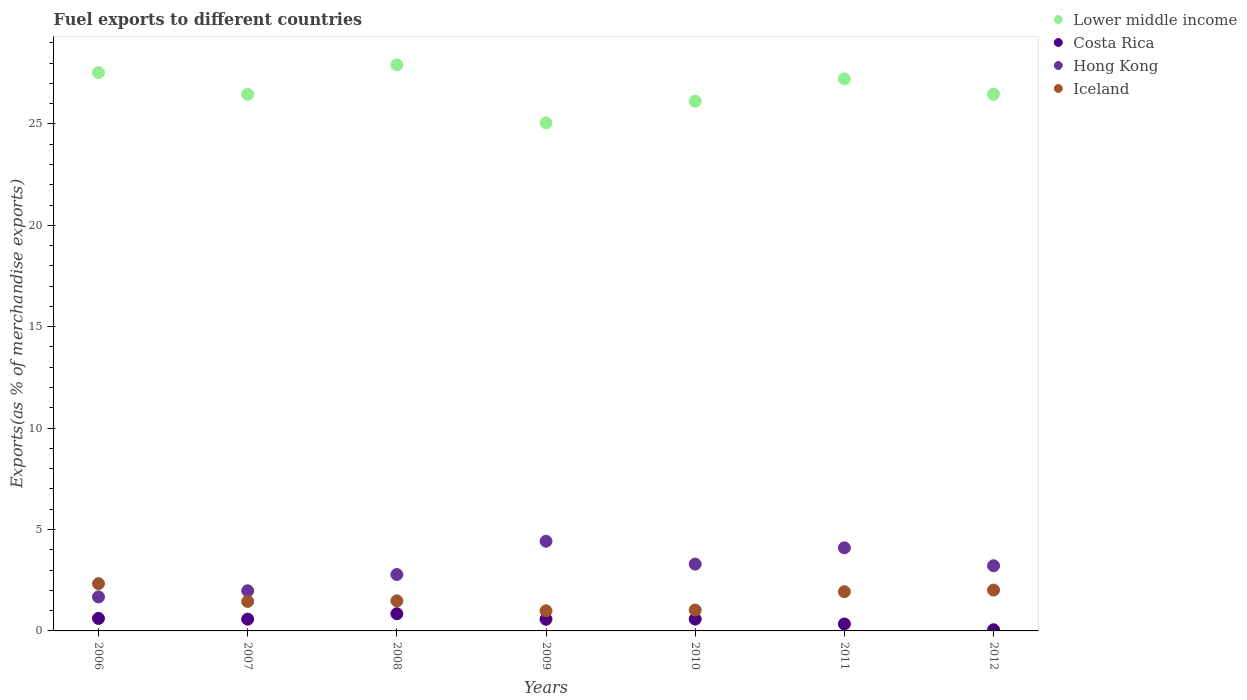How many different coloured dotlines are there?
Offer a terse response. 4. Is the number of dotlines equal to the number of legend labels?
Keep it short and to the point. Yes. What is the percentage of exports to different countries in Hong Kong in 2006?
Offer a terse response. 1.68. Across all years, what is the maximum percentage of exports to different countries in Lower middle income?
Provide a short and direct response. 27.91. Across all years, what is the minimum percentage of exports to different countries in Costa Rica?
Keep it short and to the point. 0.06. In which year was the percentage of exports to different countries in Iceland maximum?
Provide a succinct answer. 2006. In which year was the percentage of exports to different countries in Costa Rica minimum?
Your answer should be compact. 2012. What is the total percentage of exports to different countries in Hong Kong in the graph?
Make the answer very short. 21.46. What is the difference between the percentage of exports to different countries in Costa Rica in 2006 and that in 2009?
Ensure brevity in your answer.  0.04. What is the difference between the percentage of exports to different countries in Lower middle income in 2011 and the percentage of exports to different countries in Costa Rica in 2007?
Make the answer very short. 26.64. What is the average percentage of exports to different countries in Iceland per year?
Offer a terse response. 1.61. In the year 2010, what is the difference between the percentage of exports to different countries in Iceland and percentage of exports to different countries in Hong Kong?
Your response must be concise. -2.27. In how many years, is the percentage of exports to different countries in Lower middle income greater than 4 %?
Make the answer very short. 7. What is the ratio of the percentage of exports to different countries in Iceland in 2008 to that in 2009?
Ensure brevity in your answer.  1.49. What is the difference between the highest and the second highest percentage of exports to different countries in Lower middle income?
Your answer should be very brief. 0.38. What is the difference between the highest and the lowest percentage of exports to different countries in Hong Kong?
Provide a short and direct response. 2.74. Is the sum of the percentage of exports to different countries in Costa Rica in 2010 and 2012 greater than the maximum percentage of exports to different countries in Lower middle income across all years?
Your answer should be very brief. No. Is it the case that in every year, the sum of the percentage of exports to different countries in Costa Rica and percentage of exports to different countries in Hong Kong  is greater than the percentage of exports to different countries in Iceland?
Give a very brief answer. No. Is the percentage of exports to different countries in Hong Kong strictly less than the percentage of exports to different countries in Iceland over the years?
Keep it short and to the point. No. How many years are there in the graph?
Make the answer very short. 7. What is the difference between two consecutive major ticks on the Y-axis?
Provide a succinct answer. 5. Are the values on the major ticks of Y-axis written in scientific E-notation?
Your answer should be compact. No. Where does the legend appear in the graph?
Provide a succinct answer. Top right. How are the legend labels stacked?
Your answer should be compact. Vertical. What is the title of the graph?
Give a very brief answer. Fuel exports to different countries. Does "Algeria" appear as one of the legend labels in the graph?
Ensure brevity in your answer.  No. What is the label or title of the X-axis?
Your answer should be very brief. Years. What is the label or title of the Y-axis?
Offer a terse response. Exports(as % of merchandise exports). What is the Exports(as % of merchandise exports) in Lower middle income in 2006?
Offer a terse response. 27.53. What is the Exports(as % of merchandise exports) in Costa Rica in 2006?
Give a very brief answer. 0.62. What is the Exports(as % of merchandise exports) in Hong Kong in 2006?
Your answer should be compact. 1.68. What is the Exports(as % of merchandise exports) of Iceland in 2006?
Ensure brevity in your answer.  2.33. What is the Exports(as % of merchandise exports) of Lower middle income in 2007?
Your response must be concise. 26.46. What is the Exports(as % of merchandise exports) of Costa Rica in 2007?
Offer a very short reply. 0.58. What is the Exports(as % of merchandise exports) in Hong Kong in 2007?
Provide a short and direct response. 1.98. What is the Exports(as % of merchandise exports) of Iceland in 2007?
Your response must be concise. 1.45. What is the Exports(as % of merchandise exports) in Lower middle income in 2008?
Offer a terse response. 27.91. What is the Exports(as % of merchandise exports) of Costa Rica in 2008?
Ensure brevity in your answer.  0.85. What is the Exports(as % of merchandise exports) of Hong Kong in 2008?
Your answer should be very brief. 2.78. What is the Exports(as % of merchandise exports) of Iceland in 2008?
Keep it short and to the point. 1.48. What is the Exports(as % of merchandise exports) in Lower middle income in 2009?
Your response must be concise. 25.05. What is the Exports(as % of merchandise exports) in Costa Rica in 2009?
Provide a succinct answer. 0.57. What is the Exports(as % of merchandise exports) in Hong Kong in 2009?
Offer a terse response. 4.42. What is the Exports(as % of merchandise exports) of Iceland in 2009?
Give a very brief answer. 0.99. What is the Exports(as % of merchandise exports) of Lower middle income in 2010?
Offer a terse response. 26.12. What is the Exports(as % of merchandise exports) in Costa Rica in 2010?
Offer a very short reply. 0.58. What is the Exports(as % of merchandise exports) of Hong Kong in 2010?
Offer a very short reply. 3.29. What is the Exports(as % of merchandise exports) of Iceland in 2010?
Offer a terse response. 1.03. What is the Exports(as % of merchandise exports) of Lower middle income in 2011?
Keep it short and to the point. 27.22. What is the Exports(as % of merchandise exports) in Costa Rica in 2011?
Your answer should be very brief. 0.34. What is the Exports(as % of merchandise exports) in Hong Kong in 2011?
Provide a succinct answer. 4.1. What is the Exports(as % of merchandise exports) of Iceland in 2011?
Ensure brevity in your answer.  1.93. What is the Exports(as % of merchandise exports) of Lower middle income in 2012?
Provide a succinct answer. 26.46. What is the Exports(as % of merchandise exports) in Costa Rica in 2012?
Make the answer very short. 0.06. What is the Exports(as % of merchandise exports) of Hong Kong in 2012?
Provide a succinct answer. 3.21. What is the Exports(as % of merchandise exports) of Iceland in 2012?
Your answer should be compact. 2.01. Across all years, what is the maximum Exports(as % of merchandise exports) in Lower middle income?
Offer a terse response. 27.91. Across all years, what is the maximum Exports(as % of merchandise exports) of Costa Rica?
Provide a succinct answer. 0.85. Across all years, what is the maximum Exports(as % of merchandise exports) of Hong Kong?
Your answer should be compact. 4.42. Across all years, what is the maximum Exports(as % of merchandise exports) of Iceland?
Your response must be concise. 2.33. Across all years, what is the minimum Exports(as % of merchandise exports) of Lower middle income?
Your answer should be compact. 25.05. Across all years, what is the minimum Exports(as % of merchandise exports) in Costa Rica?
Ensure brevity in your answer.  0.06. Across all years, what is the minimum Exports(as % of merchandise exports) in Hong Kong?
Your response must be concise. 1.68. Across all years, what is the minimum Exports(as % of merchandise exports) of Iceland?
Your answer should be very brief. 0.99. What is the total Exports(as % of merchandise exports) in Lower middle income in the graph?
Your answer should be very brief. 186.76. What is the total Exports(as % of merchandise exports) in Costa Rica in the graph?
Your response must be concise. 3.6. What is the total Exports(as % of merchandise exports) in Hong Kong in the graph?
Your answer should be very brief. 21.46. What is the total Exports(as % of merchandise exports) in Iceland in the graph?
Provide a succinct answer. 11.24. What is the difference between the Exports(as % of merchandise exports) in Lower middle income in 2006 and that in 2007?
Keep it short and to the point. 1.07. What is the difference between the Exports(as % of merchandise exports) in Costa Rica in 2006 and that in 2007?
Keep it short and to the point. 0.04. What is the difference between the Exports(as % of merchandise exports) in Hong Kong in 2006 and that in 2007?
Make the answer very short. -0.3. What is the difference between the Exports(as % of merchandise exports) in Iceland in 2006 and that in 2007?
Ensure brevity in your answer.  0.88. What is the difference between the Exports(as % of merchandise exports) of Lower middle income in 2006 and that in 2008?
Ensure brevity in your answer.  -0.38. What is the difference between the Exports(as % of merchandise exports) in Costa Rica in 2006 and that in 2008?
Provide a short and direct response. -0.23. What is the difference between the Exports(as % of merchandise exports) in Hong Kong in 2006 and that in 2008?
Give a very brief answer. -1.1. What is the difference between the Exports(as % of merchandise exports) of Iceland in 2006 and that in 2008?
Provide a short and direct response. 0.85. What is the difference between the Exports(as % of merchandise exports) in Lower middle income in 2006 and that in 2009?
Ensure brevity in your answer.  2.48. What is the difference between the Exports(as % of merchandise exports) in Costa Rica in 2006 and that in 2009?
Make the answer very short. 0.04. What is the difference between the Exports(as % of merchandise exports) of Hong Kong in 2006 and that in 2009?
Provide a succinct answer. -2.74. What is the difference between the Exports(as % of merchandise exports) in Iceland in 2006 and that in 2009?
Offer a terse response. 1.34. What is the difference between the Exports(as % of merchandise exports) in Lower middle income in 2006 and that in 2010?
Your response must be concise. 1.41. What is the difference between the Exports(as % of merchandise exports) of Costa Rica in 2006 and that in 2010?
Provide a short and direct response. 0.03. What is the difference between the Exports(as % of merchandise exports) in Hong Kong in 2006 and that in 2010?
Keep it short and to the point. -1.62. What is the difference between the Exports(as % of merchandise exports) of Iceland in 2006 and that in 2010?
Provide a succinct answer. 1.3. What is the difference between the Exports(as % of merchandise exports) in Lower middle income in 2006 and that in 2011?
Ensure brevity in your answer.  0.31. What is the difference between the Exports(as % of merchandise exports) of Costa Rica in 2006 and that in 2011?
Give a very brief answer. 0.27. What is the difference between the Exports(as % of merchandise exports) of Hong Kong in 2006 and that in 2011?
Your response must be concise. -2.42. What is the difference between the Exports(as % of merchandise exports) of Iceland in 2006 and that in 2011?
Make the answer very short. 0.4. What is the difference between the Exports(as % of merchandise exports) of Lower middle income in 2006 and that in 2012?
Your answer should be compact. 1.07. What is the difference between the Exports(as % of merchandise exports) in Costa Rica in 2006 and that in 2012?
Provide a short and direct response. 0.56. What is the difference between the Exports(as % of merchandise exports) of Hong Kong in 2006 and that in 2012?
Keep it short and to the point. -1.54. What is the difference between the Exports(as % of merchandise exports) of Iceland in 2006 and that in 2012?
Your answer should be compact. 0.32. What is the difference between the Exports(as % of merchandise exports) in Lower middle income in 2007 and that in 2008?
Offer a very short reply. -1.45. What is the difference between the Exports(as % of merchandise exports) of Costa Rica in 2007 and that in 2008?
Offer a very short reply. -0.27. What is the difference between the Exports(as % of merchandise exports) of Hong Kong in 2007 and that in 2008?
Give a very brief answer. -0.8. What is the difference between the Exports(as % of merchandise exports) in Iceland in 2007 and that in 2008?
Make the answer very short. -0.03. What is the difference between the Exports(as % of merchandise exports) of Lower middle income in 2007 and that in 2009?
Offer a very short reply. 1.41. What is the difference between the Exports(as % of merchandise exports) of Costa Rica in 2007 and that in 2009?
Make the answer very short. 0.01. What is the difference between the Exports(as % of merchandise exports) of Hong Kong in 2007 and that in 2009?
Your answer should be very brief. -2.44. What is the difference between the Exports(as % of merchandise exports) in Iceland in 2007 and that in 2009?
Ensure brevity in your answer.  0.46. What is the difference between the Exports(as % of merchandise exports) in Lower middle income in 2007 and that in 2010?
Offer a terse response. 0.34. What is the difference between the Exports(as % of merchandise exports) of Costa Rica in 2007 and that in 2010?
Provide a succinct answer. -0. What is the difference between the Exports(as % of merchandise exports) in Hong Kong in 2007 and that in 2010?
Make the answer very short. -1.31. What is the difference between the Exports(as % of merchandise exports) of Iceland in 2007 and that in 2010?
Offer a very short reply. 0.43. What is the difference between the Exports(as % of merchandise exports) in Lower middle income in 2007 and that in 2011?
Make the answer very short. -0.76. What is the difference between the Exports(as % of merchandise exports) in Costa Rica in 2007 and that in 2011?
Offer a terse response. 0.24. What is the difference between the Exports(as % of merchandise exports) in Hong Kong in 2007 and that in 2011?
Offer a very short reply. -2.12. What is the difference between the Exports(as % of merchandise exports) in Iceland in 2007 and that in 2011?
Give a very brief answer. -0.48. What is the difference between the Exports(as % of merchandise exports) of Lower middle income in 2007 and that in 2012?
Offer a very short reply. -0. What is the difference between the Exports(as % of merchandise exports) in Costa Rica in 2007 and that in 2012?
Give a very brief answer. 0.52. What is the difference between the Exports(as % of merchandise exports) in Hong Kong in 2007 and that in 2012?
Offer a very short reply. -1.23. What is the difference between the Exports(as % of merchandise exports) in Iceland in 2007 and that in 2012?
Keep it short and to the point. -0.56. What is the difference between the Exports(as % of merchandise exports) in Lower middle income in 2008 and that in 2009?
Provide a succinct answer. 2.86. What is the difference between the Exports(as % of merchandise exports) in Costa Rica in 2008 and that in 2009?
Your answer should be very brief. 0.27. What is the difference between the Exports(as % of merchandise exports) of Hong Kong in 2008 and that in 2009?
Your answer should be very brief. -1.64. What is the difference between the Exports(as % of merchandise exports) in Iceland in 2008 and that in 2009?
Give a very brief answer. 0.49. What is the difference between the Exports(as % of merchandise exports) in Lower middle income in 2008 and that in 2010?
Your answer should be compact. 1.8. What is the difference between the Exports(as % of merchandise exports) in Costa Rica in 2008 and that in 2010?
Provide a succinct answer. 0.27. What is the difference between the Exports(as % of merchandise exports) in Hong Kong in 2008 and that in 2010?
Offer a very short reply. -0.51. What is the difference between the Exports(as % of merchandise exports) of Iceland in 2008 and that in 2010?
Offer a very short reply. 0.45. What is the difference between the Exports(as % of merchandise exports) of Lower middle income in 2008 and that in 2011?
Make the answer very short. 0.69. What is the difference between the Exports(as % of merchandise exports) of Costa Rica in 2008 and that in 2011?
Give a very brief answer. 0.51. What is the difference between the Exports(as % of merchandise exports) of Hong Kong in 2008 and that in 2011?
Offer a very short reply. -1.32. What is the difference between the Exports(as % of merchandise exports) of Iceland in 2008 and that in 2011?
Provide a succinct answer. -0.45. What is the difference between the Exports(as % of merchandise exports) in Lower middle income in 2008 and that in 2012?
Make the answer very short. 1.45. What is the difference between the Exports(as % of merchandise exports) of Costa Rica in 2008 and that in 2012?
Give a very brief answer. 0.79. What is the difference between the Exports(as % of merchandise exports) in Hong Kong in 2008 and that in 2012?
Keep it short and to the point. -0.43. What is the difference between the Exports(as % of merchandise exports) of Iceland in 2008 and that in 2012?
Keep it short and to the point. -0.53. What is the difference between the Exports(as % of merchandise exports) of Lower middle income in 2009 and that in 2010?
Your response must be concise. -1.07. What is the difference between the Exports(as % of merchandise exports) of Costa Rica in 2009 and that in 2010?
Make the answer very short. -0.01. What is the difference between the Exports(as % of merchandise exports) of Hong Kong in 2009 and that in 2010?
Provide a succinct answer. 1.13. What is the difference between the Exports(as % of merchandise exports) of Iceland in 2009 and that in 2010?
Offer a terse response. -0.04. What is the difference between the Exports(as % of merchandise exports) in Lower middle income in 2009 and that in 2011?
Keep it short and to the point. -2.17. What is the difference between the Exports(as % of merchandise exports) in Costa Rica in 2009 and that in 2011?
Make the answer very short. 0.23. What is the difference between the Exports(as % of merchandise exports) of Hong Kong in 2009 and that in 2011?
Your response must be concise. 0.32. What is the difference between the Exports(as % of merchandise exports) of Iceland in 2009 and that in 2011?
Your answer should be very brief. -0.94. What is the difference between the Exports(as % of merchandise exports) in Lower middle income in 2009 and that in 2012?
Your answer should be compact. -1.41. What is the difference between the Exports(as % of merchandise exports) in Costa Rica in 2009 and that in 2012?
Offer a very short reply. 0.52. What is the difference between the Exports(as % of merchandise exports) in Hong Kong in 2009 and that in 2012?
Your response must be concise. 1.21. What is the difference between the Exports(as % of merchandise exports) of Iceland in 2009 and that in 2012?
Give a very brief answer. -1.02. What is the difference between the Exports(as % of merchandise exports) in Lower middle income in 2010 and that in 2011?
Give a very brief answer. -1.1. What is the difference between the Exports(as % of merchandise exports) of Costa Rica in 2010 and that in 2011?
Provide a succinct answer. 0.24. What is the difference between the Exports(as % of merchandise exports) in Hong Kong in 2010 and that in 2011?
Provide a short and direct response. -0.8. What is the difference between the Exports(as % of merchandise exports) of Iceland in 2010 and that in 2011?
Your answer should be compact. -0.9. What is the difference between the Exports(as % of merchandise exports) of Lower middle income in 2010 and that in 2012?
Your response must be concise. -0.35. What is the difference between the Exports(as % of merchandise exports) in Costa Rica in 2010 and that in 2012?
Provide a succinct answer. 0.53. What is the difference between the Exports(as % of merchandise exports) of Hong Kong in 2010 and that in 2012?
Offer a very short reply. 0.08. What is the difference between the Exports(as % of merchandise exports) of Iceland in 2010 and that in 2012?
Your response must be concise. -0.99. What is the difference between the Exports(as % of merchandise exports) of Lower middle income in 2011 and that in 2012?
Provide a succinct answer. 0.76. What is the difference between the Exports(as % of merchandise exports) in Costa Rica in 2011 and that in 2012?
Ensure brevity in your answer.  0.29. What is the difference between the Exports(as % of merchandise exports) in Hong Kong in 2011 and that in 2012?
Offer a very short reply. 0.88. What is the difference between the Exports(as % of merchandise exports) in Iceland in 2011 and that in 2012?
Provide a short and direct response. -0.08. What is the difference between the Exports(as % of merchandise exports) of Lower middle income in 2006 and the Exports(as % of merchandise exports) of Costa Rica in 2007?
Your response must be concise. 26.95. What is the difference between the Exports(as % of merchandise exports) in Lower middle income in 2006 and the Exports(as % of merchandise exports) in Hong Kong in 2007?
Offer a very short reply. 25.55. What is the difference between the Exports(as % of merchandise exports) of Lower middle income in 2006 and the Exports(as % of merchandise exports) of Iceland in 2007?
Provide a succinct answer. 26.08. What is the difference between the Exports(as % of merchandise exports) of Costa Rica in 2006 and the Exports(as % of merchandise exports) of Hong Kong in 2007?
Your response must be concise. -1.36. What is the difference between the Exports(as % of merchandise exports) of Costa Rica in 2006 and the Exports(as % of merchandise exports) of Iceland in 2007?
Keep it short and to the point. -0.84. What is the difference between the Exports(as % of merchandise exports) of Hong Kong in 2006 and the Exports(as % of merchandise exports) of Iceland in 2007?
Ensure brevity in your answer.  0.22. What is the difference between the Exports(as % of merchandise exports) of Lower middle income in 2006 and the Exports(as % of merchandise exports) of Costa Rica in 2008?
Your response must be concise. 26.68. What is the difference between the Exports(as % of merchandise exports) of Lower middle income in 2006 and the Exports(as % of merchandise exports) of Hong Kong in 2008?
Your answer should be compact. 24.75. What is the difference between the Exports(as % of merchandise exports) of Lower middle income in 2006 and the Exports(as % of merchandise exports) of Iceland in 2008?
Keep it short and to the point. 26.05. What is the difference between the Exports(as % of merchandise exports) in Costa Rica in 2006 and the Exports(as % of merchandise exports) in Hong Kong in 2008?
Ensure brevity in your answer.  -2.17. What is the difference between the Exports(as % of merchandise exports) of Costa Rica in 2006 and the Exports(as % of merchandise exports) of Iceland in 2008?
Provide a succinct answer. -0.87. What is the difference between the Exports(as % of merchandise exports) of Hong Kong in 2006 and the Exports(as % of merchandise exports) of Iceland in 2008?
Your response must be concise. 0.19. What is the difference between the Exports(as % of merchandise exports) of Lower middle income in 2006 and the Exports(as % of merchandise exports) of Costa Rica in 2009?
Offer a very short reply. 26.96. What is the difference between the Exports(as % of merchandise exports) in Lower middle income in 2006 and the Exports(as % of merchandise exports) in Hong Kong in 2009?
Provide a succinct answer. 23.11. What is the difference between the Exports(as % of merchandise exports) of Lower middle income in 2006 and the Exports(as % of merchandise exports) of Iceland in 2009?
Offer a terse response. 26.54. What is the difference between the Exports(as % of merchandise exports) in Costa Rica in 2006 and the Exports(as % of merchandise exports) in Hong Kong in 2009?
Ensure brevity in your answer.  -3.81. What is the difference between the Exports(as % of merchandise exports) in Costa Rica in 2006 and the Exports(as % of merchandise exports) in Iceland in 2009?
Your answer should be compact. -0.38. What is the difference between the Exports(as % of merchandise exports) in Hong Kong in 2006 and the Exports(as % of merchandise exports) in Iceland in 2009?
Provide a short and direct response. 0.68. What is the difference between the Exports(as % of merchandise exports) of Lower middle income in 2006 and the Exports(as % of merchandise exports) of Costa Rica in 2010?
Your answer should be compact. 26.95. What is the difference between the Exports(as % of merchandise exports) of Lower middle income in 2006 and the Exports(as % of merchandise exports) of Hong Kong in 2010?
Your response must be concise. 24.24. What is the difference between the Exports(as % of merchandise exports) in Lower middle income in 2006 and the Exports(as % of merchandise exports) in Iceland in 2010?
Keep it short and to the point. 26.5. What is the difference between the Exports(as % of merchandise exports) in Costa Rica in 2006 and the Exports(as % of merchandise exports) in Hong Kong in 2010?
Your answer should be compact. -2.68. What is the difference between the Exports(as % of merchandise exports) of Costa Rica in 2006 and the Exports(as % of merchandise exports) of Iceland in 2010?
Provide a succinct answer. -0.41. What is the difference between the Exports(as % of merchandise exports) of Hong Kong in 2006 and the Exports(as % of merchandise exports) of Iceland in 2010?
Your answer should be very brief. 0.65. What is the difference between the Exports(as % of merchandise exports) of Lower middle income in 2006 and the Exports(as % of merchandise exports) of Costa Rica in 2011?
Offer a terse response. 27.19. What is the difference between the Exports(as % of merchandise exports) in Lower middle income in 2006 and the Exports(as % of merchandise exports) in Hong Kong in 2011?
Make the answer very short. 23.43. What is the difference between the Exports(as % of merchandise exports) in Lower middle income in 2006 and the Exports(as % of merchandise exports) in Iceland in 2011?
Ensure brevity in your answer.  25.6. What is the difference between the Exports(as % of merchandise exports) of Costa Rica in 2006 and the Exports(as % of merchandise exports) of Hong Kong in 2011?
Give a very brief answer. -3.48. What is the difference between the Exports(as % of merchandise exports) in Costa Rica in 2006 and the Exports(as % of merchandise exports) in Iceland in 2011?
Offer a very short reply. -1.32. What is the difference between the Exports(as % of merchandise exports) of Hong Kong in 2006 and the Exports(as % of merchandise exports) of Iceland in 2011?
Keep it short and to the point. -0.26. What is the difference between the Exports(as % of merchandise exports) of Lower middle income in 2006 and the Exports(as % of merchandise exports) of Costa Rica in 2012?
Give a very brief answer. 27.47. What is the difference between the Exports(as % of merchandise exports) of Lower middle income in 2006 and the Exports(as % of merchandise exports) of Hong Kong in 2012?
Keep it short and to the point. 24.32. What is the difference between the Exports(as % of merchandise exports) in Lower middle income in 2006 and the Exports(as % of merchandise exports) in Iceland in 2012?
Offer a very short reply. 25.52. What is the difference between the Exports(as % of merchandise exports) of Costa Rica in 2006 and the Exports(as % of merchandise exports) of Hong Kong in 2012?
Give a very brief answer. -2.6. What is the difference between the Exports(as % of merchandise exports) in Costa Rica in 2006 and the Exports(as % of merchandise exports) in Iceland in 2012?
Offer a very short reply. -1.4. What is the difference between the Exports(as % of merchandise exports) in Hong Kong in 2006 and the Exports(as % of merchandise exports) in Iceland in 2012?
Your response must be concise. -0.34. What is the difference between the Exports(as % of merchandise exports) of Lower middle income in 2007 and the Exports(as % of merchandise exports) of Costa Rica in 2008?
Your response must be concise. 25.61. What is the difference between the Exports(as % of merchandise exports) of Lower middle income in 2007 and the Exports(as % of merchandise exports) of Hong Kong in 2008?
Keep it short and to the point. 23.68. What is the difference between the Exports(as % of merchandise exports) in Lower middle income in 2007 and the Exports(as % of merchandise exports) in Iceland in 2008?
Give a very brief answer. 24.98. What is the difference between the Exports(as % of merchandise exports) of Costa Rica in 2007 and the Exports(as % of merchandise exports) of Hong Kong in 2008?
Give a very brief answer. -2.2. What is the difference between the Exports(as % of merchandise exports) of Costa Rica in 2007 and the Exports(as % of merchandise exports) of Iceland in 2008?
Your answer should be very brief. -0.9. What is the difference between the Exports(as % of merchandise exports) in Hong Kong in 2007 and the Exports(as % of merchandise exports) in Iceland in 2008?
Keep it short and to the point. 0.5. What is the difference between the Exports(as % of merchandise exports) of Lower middle income in 2007 and the Exports(as % of merchandise exports) of Costa Rica in 2009?
Offer a very short reply. 25.89. What is the difference between the Exports(as % of merchandise exports) of Lower middle income in 2007 and the Exports(as % of merchandise exports) of Hong Kong in 2009?
Provide a succinct answer. 22.04. What is the difference between the Exports(as % of merchandise exports) of Lower middle income in 2007 and the Exports(as % of merchandise exports) of Iceland in 2009?
Ensure brevity in your answer.  25.47. What is the difference between the Exports(as % of merchandise exports) of Costa Rica in 2007 and the Exports(as % of merchandise exports) of Hong Kong in 2009?
Provide a short and direct response. -3.84. What is the difference between the Exports(as % of merchandise exports) of Costa Rica in 2007 and the Exports(as % of merchandise exports) of Iceland in 2009?
Your answer should be very brief. -0.41. What is the difference between the Exports(as % of merchandise exports) of Hong Kong in 2007 and the Exports(as % of merchandise exports) of Iceland in 2009?
Your answer should be very brief. 0.99. What is the difference between the Exports(as % of merchandise exports) in Lower middle income in 2007 and the Exports(as % of merchandise exports) in Costa Rica in 2010?
Your answer should be compact. 25.88. What is the difference between the Exports(as % of merchandise exports) of Lower middle income in 2007 and the Exports(as % of merchandise exports) of Hong Kong in 2010?
Your answer should be very brief. 23.17. What is the difference between the Exports(as % of merchandise exports) of Lower middle income in 2007 and the Exports(as % of merchandise exports) of Iceland in 2010?
Offer a very short reply. 25.43. What is the difference between the Exports(as % of merchandise exports) of Costa Rica in 2007 and the Exports(as % of merchandise exports) of Hong Kong in 2010?
Keep it short and to the point. -2.71. What is the difference between the Exports(as % of merchandise exports) in Costa Rica in 2007 and the Exports(as % of merchandise exports) in Iceland in 2010?
Your answer should be compact. -0.45. What is the difference between the Exports(as % of merchandise exports) in Hong Kong in 2007 and the Exports(as % of merchandise exports) in Iceland in 2010?
Offer a very short reply. 0.95. What is the difference between the Exports(as % of merchandise exports) of Lower middle income in 2007 and the Exports(as % of merchandise exports) of Costa Rica in 2011?
Provide a succinct answer. 26.12. What is the difference between the Exports(as % of merchandise exports) of Lower middle income in 2007 and the Exports(as % of merchandise exports) of Hong Kong in 2011?
Provide a short and direct response. 22.36. What is the difference between the Exports(as % of merchandise exports) in Lower middle income in 2007 and the Exports(as % of merchandise exports) in Iceland in 2011?
Make the answer very short. 24.53. What is the difference between the Exports(as % of merchandise exports) in Costa Rica in 2007 and the Exports(as % of merchandise exports) in Hong Kong in 2011?
Provide a succinct answer. -3.52. What is the difference between the Exports(as % of merchandise exports) of Costa Rica in 2007 and the Exports(as % of merchandise exports) of Iceland in 2011?
Your answer should be very brief. -1.35. What is the difference between the Exports(as % of merchandise exports) in Hong Kong in 2007 and the Exports(as % of merchandise exports) in Iceland in 2011?
Provide a succinct answer. 0.05. What is the difference between the Exports(as % of merchandise exports) of Lower middle income in 2007 and the Exports(as % of merchandise exports) of Costa Rica in 2012?
Your response must be concise. 26.4. What is the difference between the Exports(as % of merchandise exports) of Lower middle income in 2007 and the Exports(as % of merchandise exports) of Hong Kong in 2012?
Give a very brief answer. 23.25. What is the difference between the Exports(as % of merchandise exports) of Lower middle income in 2007 and the Exports(as % of merchandise exports) of Iceland in 2012?
Your response must be concise. 24.45. What is the difference between the Exports(as % of merchandise exports) of Costa Rica in 2007 and the Exports(as % of merchandise exports) of Hong Kong in 2012?
Ensure brevity in your answer.  -2.63. What is the difference between the Exports(as % of merchandise exports) in Costa Rica in 2007 and the Exports(as % of merchandise exports) in Iceland in 2012?
Your response must be concise. -1.43. What is the difference between the Exports(as % of merchandise exports) in Hong Kong in 2007 and the Exports(as % of merchandise exports) in Iceland in 2012?
Provide a short and direct response. -0.03. What is the difference between the Exports(as % of merchandise exports) in Lower middle income in 2008 and the Exports(as % of merchandise exports) in Costa Rica in 2009?
Keep it short and to the point. 27.34. What is the difference between the Exports(as % of merchandise exports) in Lower middle income in 2008 and the Exports(as % of merchandise exports) in Hong Kong in 2009?
Give a very brief answer. 23.49. What is the difference between the Exports(as % of merchandise exports) of Lower middle income in 2008 and the Exports(as % of merchandise exports) of Iceland in 2009?
Your response must be concise. 26.92. What is the difference between the Exports(as % of merchandise exports) of Costa Rica in 2008 and the Exports(as % of merchandise exports) of Hong Kong in 2009?
Your response must be concise. -3.57. What is the difference between the Exports(as % of merchandise exports) of Costa Rica in 2008 and the Exports(as % of merchandise exports) of Iceland in 2009?
Give a very brief answer. -0.14. What is the difference between the Exports(as % of merchandise exports) of Hong Kong in 2008 and the Exports(as % of merchandise exports) of Iceland in 2009?
Offer a terse response. 1.79. What is the difference between the Exports(as % of merchandise exports) of Lower middle income in 2008 and the Exports(as % of merchandise exports) of Costa Rica in 2010?
Your answer should be very brief. 27.33. What is the difference between the Exports(as % of merchandise exports) of Lower middle income in 2008 and the Exports(as % of merchandise exports) of Hong Kong in 2010?
Offer a terse response. 24.62. What is the difference between the Exports(as % of merchandise exports) in Lower middle income in 2008 and the Exports(as % of merchandise exports) in Iceland in 2010?
Provide a succinct answer. 26.88. What is the difference between the Exports(as % of merchandise exports) in Costa Rica in 2008 and the Exports(as % of merchandise exports) in Hong Kong in 2010?
Offer a very short reply. -2.45. What is the difference between the Exports(as % of merchandise exports) in Costa Rica in 2008 and the Exports(as % of merchandise exports) in Iceland in 2010?
Ensure brevity in your answer.  -0.18. What is the difference between the Exports(as % of merchandise exports) of Hong Kong in 2008 and the Exports(as % of merchandise exports) of Iceland in 2010?
Keep it short and to the point. 1.75. What is the difference between the Exports(as % of merchandise exports) in Lower middle income in 2008 and the Exports(as % of merchandise exports) in Costa Rica in 2011?
Provide a short and direct response. 27.57. What is the difference between the Exports(as % of merchandise exports) in Lower middle income in 2008 and the Exports(as % of merchandise exports) in Hong Kong in 2011?
Your answer should be very brief. 23.82. What is the difference between the Exports(as % of merchandise exports) of Lower middle income in 2008 and the Exports(as % of merchandise exports) of Iceland in 2011?
Give a very brief answer. 25.98. What is the difference between the Exports(as % of merchandise exports) of Costa Rica in 2008 and the Exports(as % of merchandise exports) of Hong Kong in 2011?
Offer a very short reply. -3.25. What is the difference between the Exports(as % of merchandise exports) in Costa Rica in 2008 and the Exports(as % of merchandise exports) in Iceland in 2011?
Ensure brevity in your answer.  -1.08. What is the difference between the Exports(as % of merchandise exports) of Hong Kong in 2008 and the Exports(as % of merchandise exports) of Iceland in 2011?
Ensure brevity in your answer.  0.85. What is the difference between the Exports(as % of merchandise exports) in Lower middle income in 2008 and the Exports(as % of merchandise exports) in Costa Rica in 2012?
Give a very brief answer. 27.86. What is the difference between the Exports(as % of merchandise exports) in Lower middle income in 2008 and the Exports(as % of merchandise exports) in Hong Kong in 2012?
Make the answer very short. 24.7. What is the difference between the Exports(as % of merchandise exports) of Lower middle income in 2008 and the Exports(as % of merchandise exports) of Iceland in 2012?
Your answer should be very brief. 25.9. What is the difference between the Exports(as % of merchandise exports) of Costa Rica in 2008 and the Exports(as % of merchandise exports) of Hong Kong in 2012?
Provide a succinct answer. -2.36. What is the difference between the Exports(as % of merchandise exports) of Costa Rica in 2008 and the Exports(as % of merchandise exports) of Iceland in 2012?
Offer a terse response. -1.17. What is the difference between the Exports(as % of merchandise exports) of Hong Kong in 2008 and the Exports(as % of merchandise exports) of Iceland in 2012?
Ensure brevity in your answer.  0.77. What is the difference between the Exports(as % of merchandise exports) of Lower middle income in 2009 and the Exports(as % of merchandise exports) of Costa Rica in 2010?
Offer a terse response. 24.47. What is the difference between the Exports(as % of merchandise exports) in Lower middle income in 2009 and the Exports(as % of merchandise exports) in Hong Kong in 2010?
Offer a very short reply. 21.76. What is the difference between the Exports(as % of merchandise exports) of Lower middle income in 2009 and the Exports(as % of merchandise exports) of Iceland in 2010?
Give a very brief answer. 24.02. What is the difference between the Exports(as % of merchandise exports) in Costa Rica in 2009 and the Exports(as % of merchandise exports) in Hong Kong in 2010?
Provide a short and direct response. -2.72. What is the difference between the Exports(as % of merchandise exports) in Costa Rica in 2009 and the Exports(as % of merchandise exports) in Iceland in 2010?
Provide a succinct answer. -0.45. What is the difference between the Exports(as % of merchandise exports) in Hong Kong in 2009 and the Exports(as % of merchandise exports) in Iceland in 2010?
Your answer should be compact. 3.39. What is the difference between the Exports(as % of merchandise exports) in Lower middle income in 2009 and the Exports(as % of merchandise exports) in Costa Rica in 2011?
Provide a short and direct response. 24.71. What is the difference between the Exports(as % of merchandise exports) in Lower middle income in 2009 and the Exports(as % of merchandise exports) in Hong Kong in 2011?
Your answer should be very brief. 20.95. What is the difference between the Exports(as % of merchandise exports) of Lower middle income in 2009 and the Exports(as % of merchandise exports) of Iceland in 2011?
Offer a very short reply. 23.12. What is the difference between the Exports(as % of merchandise exports) in Costa Rica in 2009 and the Exports(as % of merchandise exports) in Hong Kong in 2011?
Provide a short and direct response. -3.52. What is the difference between the Exports(as % of merchandise exports) in Costa Rica in 2009 and the Exports(as % of merchandise exports) in Iceland in 2011?
Keep it short and to the point. -1.36. What is the difference between the Exports(as % of merchandise exports) of Hong Kong in 2009 and the Exports(as % of merchandise exports) of Iceland in 2011?
Your answer should be compact. 2.49. What is the difference between the Exports(as % of merchandise exports) of Lower middle income in 2009 and the Exports(as % of merchandise exports) of Costa Rica in 2012?
Give a very brief answer. 24.99. What is the difference between the Exports(as % of merchandise exports) in Lower middle income in 2009 and the Exports(as % of merchandise exports) in Hong Kong in 2012?
Provide a short and direct response. 21.84. What is the difference between the Exports(as % of merchandise exports) of Lower middle income in 2009 and the Exports(as % of merchandise exports) of Iceland in 2012?
Make the answer very short. 23.04. What is the difference between the Exports(as % of merchandise exports) of Costa Rica in 2009 and the Exports(as % of merchandise exports) of Hong Kong in 2012?
Your answer should be compact. -2.64. What is the difference between the Exports(as % of merchandise exports) in Costa Rica in 2009 and the Exports(as % of merchandise exports) in Iceland in 2012?
Make the answer very short. -1.44. What is the difference between the Exports(as % of merchandise exports) in Hong Kong in 2009 and the Exports(as % of merchandise exports) in Iceland in 2012?
Make the answer very short. 2.41. What is the difference between the Exports(as % of merchandise exports) in Lower middle income in 2010 and the Exports(as % of merchandise exports) in Costa Rica in 2011?
Ensure brevity in your answer.  25.77. What is the difference between the Exports(as % of merchandise exports) of Lower middle income in 2010 and the Exports(as % of merchandise exports) of Hong Kong in 2011?
Ensure brevity in your answer.  22.02. What is the difference between the Exports(as % of merchandise exports) of Lower middle income in 2010 and the Exports(as % of merchandise exports) of Iceland in 2011?
Provide a short and direct response. 24.18. What is the difference between the Exports(as % of merchandise exports) in Costa Rica in 2010 and the Exports(as % of merchandise exports) in Hong Kong in 2011?
Make the answer very short. -3.52. What is the difference between the Exports(as % of merchandise exports) in Costa Rica in 2010 and the Exports(as % of merchandise exports) in Iceland in 2011?
Your answer should be compact. -1.35. What is the difference between the Exports(as % of merchandise exports) in Hong Kong in 2010 and the Exports(as % of merchandise exports) in Iceland in 2011?
Your answer should be very brief. 1.36. What is the difference between the Exports(as % of merchandise exports) of Lower middle income in 2010 and the Exports(as % of merchandise exports) of Costa Rica in 2012?
Provide a short and direct response. 26.06. What is the difference between the Exports(as % of merchandise exports) of Lower middle income in 2010 and the Exports(as % of merchandise exports) of Hong Kong in 2012?
Ensure brevity in your answer.  22.9. What is the difference between the Exports(as % of merchandise exports) of Lower middle income in 2010 and the Exports(as % of merchandise exports) of Iceland in 2012?
Make the answer very short. 24.1. What is the difference between the Exports(as % of merchandise exports) of Costa Rica in 2010 and the Exports(as % of merchandise exports) of Hong Kong in 2012?
Offer a terse response. -2.63. What is the difference between the Exports(as % of merchandise exports) in Costa Rica in 2010 and the Exports(as % of merchandise exports) in Iceland in 2012?
Give a very brief answer. -1.43. What is the difference between the Exports(as % of merchandise exports) in Hong Kong in 2010 and the Exports(as % of merchandise exports) in Iceland in 2012?
Make the answer very short. 1.28. What is the difference between the Exports(as % of merchandise exports) in Lower middle income in 2011 and the Exports(as % of merchandise exports) in Costa Rica in 2012?
Your response must be concise. 27.17. What is the difference between the Exports(as % of merchandise exports) of Lower middle income in 2011 and the Exports(as % of merchandise exports) of Hong Kong in 2012?
Ensure brevity in your answer.  24.01. What is the difference between the Exports(as % of merchandise exports) of Lower middle income in 2011 and the Exports(as % of merchandise exports) of Iceland in 2012?
Provide a succinct answer. 25.21. What is the difference between the Exports(as % of merchandise exports) of Costa Rica in 2011 and the Exports(as % of merchandise exports) of Hong Kong in 2012?
Give a very brief answer. -2.87. What is the difference between the Exports(as % of merchandise exports) in Costa Rica in 2011 and the Exports(as % of merchandise exports) in Iceland in 2012?
Your answer should be compact. -1.67. What is the difference between the Exports(as % of merchandise exports) of Hong Kong in 2011 and the Exports(as % of merchandise exports) of Iceland in 2012?
Your answer should be compact. 2.08. What is the average Exports(as % of merchandise exports) in Lower middle income per year?
Provide a succinct answer. 26.68. What is the average Exports(as % of merchandise exports) of Costa Rica per year?
Make the answer very short. 0.51. What is the average Exports(as % of merchandise exports) in Hong Kong per year?
Ensure brevity in your answer.  3.07. What is the average Exports(as % of merchandise exports) of Iceland per year?
Offer a very short reply. 1.61. In the year 2006, what is the difference between the Exports(as % of merchandise exports) of Lower middle income and Exports(as % of merchandise exports) of Costa Rica?
Your response must be concise. 26.91. In the year 2006, what is the difference between the Exports(as % of merchandise exports) of Lower middle income and Exports(as % of merchandise exports) of Hong Kong?
Ensure brevity in your answer.  25.85. In the year 2006, what is the difference between the Exports(as % of merchandise exports) in Lower middle income and Exports(as % of merchandise exports) in Iceland?
Provide a succinct answer. 25.2. In the year 2006, what is the difference between the Exports(as % of merchandise exports) of Costa Rica and Exports(as % of merchandise exports) of Hong Kong?
Provide a succinct answer. -1.06. In the year 2006, what is the difference between the Exports(as % of merchandise exports) of Costa Rica and Exports(as % of merchandise exports) of Iceland?
Give a very brief answer. -1.72. In the year 2006, what is the difference between the Exports(as % of merchandise exports) of Hong Kong and Exports(as % of merchandise exports) of Iceland?
Give a very brief answer. -0.65. In the year 2007, what is the difference between the Exports(as % of merchandise exports) in Lower middle income and Exports(as % of merchandise exports) in Costa Rica?
Offer a very short reply. 25.88. In the year 2007, what is the difference between the Exports(as % of merchandise exports) of Lower middle income and Exports(as % of merchandise exports) of Hong Kong?
Provide a short and direct response. 24.48. In the year 2007, what is the difference between the Exports(as % of merchandise exports) of Lower middle income and Exports(as % of merchandise exports) of Iceland?
Your response must be concise. 25.01. In the year 2007, what is the difference between the Exports(as % of merchandise exports) in Costa Rica and Exports(as % of merchandise exports) in Hong Kong?
Make the answer very short. -1.4. In the year 2007, what is the difference between the Exports(as % of merchandise exports) of Costa Rica and Exports(as % of merchandise exports) of Iceland?
Offer a terse response. -0.87. In the year 2007, what is the difference between the Exports(as % of merchandise exports) in Hong Kong and Exports(as % of merchandise exports) in Iceland?
Keep it short and to the point. 0.53. In the year 2008, what is the difference between the Exports(as % of merchandise exports) in Lower middle income and Exports(as % of merchandise exports) in Costa Rica?
Offer a terse response. 27.06. In the year 2008, what is the difference between the Exports(as % of merchandise exports) of Lower middle income and Exports(as % of merchandise exports) of Hong Kong?
Ensure brevity in your answer.  25.13. In the year 2008, what is the difference between the Exports(as % of merchandise exports) of Lower middle income and Exports(as % of merchandise exports) of Iceland?
Make the answer very short. 26.43. In the year 2008, what is the difference between the Exports(as % of merchandise exports) in Costa Rica and Exports(as % of merchandise exports) in Hong Kong?
Provide a succinct answer. -1.93. In the year 2008, what is the difference between the Exports(as % of merchandise exports) in Costa Rica and Exports(as % of merchandise exports) in Iceland?
Keep it short and to the point. -0.63. In the year 2008, what is the difference between the Exports(as % of merchandise exports) of Hong Kong and Exports(as % of merchandise exports) of Iceland?
Your answer should be very brief. 1.3. In the year 2009, what is the difference between the Exports(as % of merchandise exports) of Lower middle income and Exports(as % of merchandise exports) of Costa Rica?
Keep it short and to the point. 24.48. In the year 2009, what is the difference between the Exports(as % of merchandise exports) of Lower middle income and Exports(as % of merchandise exports) of Hong Kong?
Your answer should be compact. 20.63. In the year 2009, what is the difference between the Exports(as % of merchandise exports) in Lower middle income and Exports(as % of merchandise exports) in Iceland?
Keep it short and to the point. 24.06. In the year 2009, what is the difference between the Exports(as % of merchandise exports) of Costa Rica and Exports(as % of merchandise exports) of Hong Kong?
Your answer should be compact. -3.85. In the year 2009, what is the difference between the Exports(as % of merchandise exports) in Costa Rica and Exports(as % of merchandise exports) in Iceland?
Provide a succinct answer. -0.42. In the year 2009, what is the difference between the Exports(as % of merchandise exports) of Hong Kong and Exports(as % of merchandise exports) of Iceland?
Ensure brevity in your answer.  3.43. In the year 2010, what is the difference between the Exports(as % of merchandise exports) of Lower middle income and Exports(as % of merchandise exports) of Costa Rica?
Keep it short and to the point. 25.53. In the year 2010, what is the difference between the Exports(as % of merchandise exports) of Lower middle income and Exports(as % of merchandise exports) of Hong Kong?
Ensure brevity in your answer.  22.82. In the year 2010, what is the difference between the Exports(as % of merchandise exports) of Lower middle income and Exports(as % of merchandise exports) of Iceland?
Ensure brevity in your answer.  25.09. In the year 2010, what is the difference between the Exports(as % of merchandise exports) in Costa Rica and Exports(as % of merchandise exports) in Hong Kong?
Keep it short and to the point. -2.71. In the year 2010, what is the difference between the Exports(as % of merchandise exports) of Costa Rica and Exports(as % of merchandise exports) of Iceland?
Your response must be concise. -0.45. In the year 2010, what is the difference between the Exports(as % of merchandise exports) in Hong Kong and Exports(as % of merchandise exports) in Iceland?
Your answer should be very brief. 2.27. In the year 2011, what is the difference between the Exports(as % of merchandise exports) of Lower middle income and Exports(as % of merchandise exports) of Costa Rica?
Provide a short and direct response. 26.88. In the year 2011, what is the difference between the Exports(as % of merchandise exports) of Lower middle income and Exports(as % of merchandise exports) of Hong Kong?
Your answer should be very brief. 23.12. In the year 2011, what is the difference between the Exports(as % of merchandise exports) of Lower middle income and Exports(as % of merchandise exports) of Iceland?
Ensure brevity in your answer.  25.29. In the year 2011, what is the difference between the Exports(as % of merchandise exports) of Costa Rica and Exports(as % of merchandise exports) of Hong Kong?
Make the answer very short. -3.76. In the year 2011, what is the difference between the Exports(as % of merchandise exports) in Costa Rica and Exports(as % of merchandise exports) in Iceland?
Your answer should be compact. -1.59. In the year 2011, what is the difference between the Exports(as % of merchandise exports) in Hong Kong and Exports(as % of merchandise exports) in Iceland?
Make the answer very short. 2.16. In the year 2012, what is the difference between the Exports(as % of merchandise exports) in Lower middle income and Exports(as % of merchandise exports) in Costa Rica?
Keep it short and to the point. 26.41. In the year 2012, what is the difference between the Exports(as % of merchandise exports) of Lower middle income and Exports(as % of merchandise exports) of Hong Kong?
Offer a terse response. 23.25. In the year 2012, what is the difference between the Exports(as % of merchandise exports) of Lower middle income and Exports(as % of merchandise exports) of Iceland?
Offer a very short reply. 24.45. In the year 2012, what is the difference between the Exports(as % of merchandise exports) in Costa Rica and Exports(as % of merchandise exports) in Hong Kong?
Provide a succinct answer. -3.16. In the year 2012, what is the difference between the Exports(as % of merchandise exports) of Costa Rica and Exports(as % of merchandise exports) of Iceland?
Offer a very short reply. -1.96. In the year 2012, what is the difference between the Exports(as % of merchandise exports) in Hong Kong and Exports(as % of merchandise exports) in Iceland?
Keep it short and to the point. 1.2. What is the ratio of the Exports(as % of merchandise exports) in Lower middle income in 2006 to that in 2007?
Provide a short and direct response. 1.04. What is the ratio of the Exports(as % of merchandise exports) of Costa Rica in 2006 to that in 2007?
Your response must be concise. 1.06. What is the ratio of the Exports(as % of merchandise exports) in Hong Kong in 2006 to that in 2007?
Your answer should be very brief. 0.85. What is the ratio of the Exports(as % of merchandise exports) in Iceland in 2006 to that in 2007?
Make the answer very short. 1.6. What is the ratio of the Exports(as % of merchandise exports) in Lower middle income in 2006 to that in 2008?
Offer a terse response. 0.99. What is the ratio of the Exports(as % of merchandise exports) in Costa Rica in 2006 to that in 2008?
Your answer should be very brief. 0.73. What is the ratio of the Exports(as % of merchandise exports) of Hong Kong in 2006 to that in 2008?
Your response must be concise. 0.6. What is the ratio of the Exports(as % of merchandise exports) of Iceland in 2006 to that in 2008?
Your answer should be compact. 1.57. What is the ratio of the Exports(as % of merchandise exports) in Lower middle income in 2006 to that in 2009?
Keep it short and to the point. 1.1. What is the ratio of the Exports(as % of merchandise exports) in Costa Rica in 2006 to that in 2009?
Give a very brief answer. 1.07. What is the ratio of the Exports(as % of merchandise exports) in Hong Kong in 2006 to that in 2009?
Provide a short and direct response. 0.38. What is the ratio of the Exports(as % of merchandise exports) of Iceland in 2006 to that in 2009?
Provide a short and direct response. 2.35. What is the ratio of the Exports(as % of merchandise exports) in Lower middle income in 2006 to that in 2010?
Ensure brevity in your answer.  1.05. What is the ratio of the Exports(as % of merchandise exports) of Costa Rica in 2006 to that in 2010?
Make the answer very short. 1.06. What is the ratio of the Exports(as % of merchandise exports) in Hong Kong in 2006 to that in 2010?
Provide a succinct answer. 0.51. What is the ratio of the Exports(as % of merchandise exports) in Iceland in 2006 to that in 2010?
Your answer should be compact. 2.27. What is the ratio of the Exports(as % of merchandise exports) of Lower middle income in 2006 to that in 2011?
Keep it short and to the point. 1.01. What is the ratio of the Exports(as % of merchandise exports) in Costa Rica in 2006 to that in 2011?
Your answer should be very brief. 1.8. What is the ratio of the Exports(as % of merchandise exports) of Hong Kong in 2006 to that in 2011?
Your answer should be compact. 0.41. What is the ratio of the Exports(as % of merchandise exports) in Iceland in 2006 to that in 2011?
Give a very brief answer. 1.21. What is the ratio of the Exports(as % of merchandise exports) in Lower middle income in 2006 to that in 2012?
Make the answer very short. 1.04. What is the ratio of the Exports(as % of merchandise exports) of Costa Rica in 2006 to that in 2012?
Offer a very short reply. 10.88. What is the ratio of the Exports(as % of merchandise exports) of Hong Kong in 2006 to that in 2012?
Your answer should be very brief. 0.52. What is the ratio of the Exports(as % of merchandise exports) of Iceland in 2006 to that in 2012?
Offer a terse response. 1.16. What is the ratio of the Exports(as % of merchandise exports) in Lower middle income in 2007 to that in 2008?
Your answer should be very brief. 0.95. What is the ratio of the Exports(as % of merchandise exports) in Costa Rica in 2007 to that in 2008?
Make the answer very short. 0.68. What is the ratio of the Exports(as % of merchandise exports) in Hong Kong in 2007 to that in 2008?
Make the answer very short. 0.71. What is the ratio of the Exports(as % of merchandise exports) of Iceland in 2007 to that in 2008?
Your answer should be very brief. 0.98. What is the ratio of the Exports(as % of merchandise exports) of Lower middle income in 2007 to that in 2009?
Offer a terse response. 1.06. What is the ratio of the Exports(as % of merchandise exports) of Costa Rica in 2007 to that in 2009?
Provide a short and direct response. 1.01. What is the ratio of the Exports(as % of merchandise exports) of Hong Kong in 2007 to that in 2009?
Provide a succinct answer. 0.45. What is the ratio of the Exports(as % of merchandise exports) of Iceland in 2007 to that in 2009?
Provide a succinct answer. 1.47. What is the ratio of the Exports(as % of merchandise exports) in Lower middle income in 2007 to that in 2010?
Provide a succinct answer. 1.01. What is the ratio of the Exports(as % of merchandise exports) in Hong Kong in 2007 to that in 2010?
Offer a very short reply. 0.6. What is the ratio of the Exports(as % of merchandise exports) of Iceland in 2007 to that in 2010?
Provide a short and direct response. 1.41. What is the ratio of the Exports(as % of merchandise exports) of Costa Rica in 2007 to that in 2011?
Your response must be concise. 1.7. What is the ratio of the Exports(as % of merchandise exports) in Hong Kong in 2007 to that in 2011?
Offer a terse response. 0.48. What is the ratio of the Exports(as % of merchandise exports) in Iceland in 2007 to that in 2011?
Provide a short and direct response. 0.75. What is the ratio of the Exports(as % of merchandise exports) of Lower middle income in 2007 to that in 2012?
Offer a terse response. 1. What is the ratio of the Exports(as % of merchandise exports) of Costa Rica in 2007 to that in 2012?
Offer a terse response. 10.25. What is the ratio of the Exports(as % of merchandise exports) in Hong Kong in 2007 to that in 2012?
Your answer should be compact. 0.62. What is the ratio of the Exports(as % of merchandise exports) in Iceland in 2007 to that in 2012?
Offer a very short reply. 0.72. What is the ratio of the Exports(as % of merchandise exports) in Lower middle income in 2008 to that in 2009?
Ensure brevity in your answer.  1.11. What is the ratio of the Exports(as % of merchandise exports) in Costa Rica in 2008 to that in 2009?
Offer a terse response. 1.48. What is the ratio of the Exports(as % of merchandise exports) of Hong Kong in 2008 to that in 2009?
Provide a short and direct response. 0.63. What is the ratio of the Exports(as % of merchandise exports) in Iceland in 2008 to that in 2009?
Your answer should be compact. 1.5. What is the ratio of the Exports(as % of merchandise exports) of Lower middle income in 2008 to that in 2010?
Your response must be concise. 1.07. What is the ratio of the Exports(as % of merchandise exports) of Costa Rica in 2008 to that in 2010?
Give a very brief answer. 1.46. What is the ratio of the Exports(as % of merchandise exports) of Hong Kong in 2008 to that in 2010?
Provide a succinct answer. 0.84. What is the ratio of the Exports(as % of merchandise exports) of Iceland in 2008 to that in 2010?
Your answer should be very brief. 1.44. What is the ratio of the Exports(as % of merchandise exports) in Lower middle income in 2008 to that in 2011?
Give a very brief answer. 1.03. What is the ratio of the Exports(as % of merchandise exports) in Costa Rica in 2008 to that in 2011?
Provide a short and direct response. 2.48. What is the ratio of the Exports(as % of merchandise exports) of Hong Kong in 2008 to that in 2011?
Provide a short and direct response. 0.68. What is the ratio of the Exports(as % of merchandise exports) in Iceland in 2008 to that in 2011?
Offer a very short reply. 0.77. What is the ratio of the Exports(as % of merchandise exports) of Lower middle income in 2008 to that in 2012?
Your answer should be compact. 1.05. What is the ratio of the Exports(as % of merchandise exports) in Costa Rica in 2008 to that in 2012?
Your answer should be very brief. 14.99. What is the ratio of the Exports(as % of merchandise exports) of Hong Kong in 2008 to that in 2012?
Ensure brevity in your answer.  0.87. What is the ratio of the Exports(as % of merchandise exports) of Iceland in 2008 to that in 2012?
Your answer should be very brief. 0.74. What is the ratio of the Exports(as % of merchandise exports) of Lower middle income in 2009 to that in 2010?
Offer a terse response. 0.96. What is the ratio of the Exports(as % of merchandise exports) of Costa Rica in 2009 to that in 2010?
Provide a succinct answer. 0.99. What is the ratio of the Exports(as % of merchandise exports) of Hong Kong in 2009 to that in 2010?
Your answer should be very brief. 1.34. What is the ratio of the Exports(as % of merchandise exports) in Iceland in 2009 to that in 2010?
Ensure brevity in your answer.  0.96. What is the ratio of the Exports(as % of merchandise exports) of Lower middle income in 2009 to that in 2011?
Ensure brevity in your answer.  0.92. What is the ratio of the Exports(as % of merchandise exports) in Costa Rica in 2009 to that in 2011?
Your answer should be compact. 1.68. What is the ratio of the Exports(as % of merchandise exports) in Hong Kong in 2009 to that in 2011?
Keep it short and to the point. 1.08. What is the ratio of the Exports(as % of merchandise exports) of Iceland in 2009 to that in 2011?
Give a very brief answer. 0.51. What is the ratio of the Exports(as % of merchandise exports) of Lower middle income in 2009 to that in 2012?
Offer a very short reply. 0.95. What is the ratio of the Exports(as % of merchandise exports) in Costa Rica in 2009 to that in 2012?
Make the answer very short. 10.14. What is the ratio of the Exports(as % of merchandise exports) in Hong Kong in 2009 to that in 2012?
Make the answer very short. 1.38. What is the ratio of the Exports(as % of merchandise exports) of Iceland in 2009 to that in 2012?
Give a very brief answer. 0.49. What is the ratio of the Exports(as % of merchandise exports) in Lower middle income in 2010 to that in 2011?
Offer a terse response. 0.96. What is the ratio of the Exports(as % of merchandise exports) in Costa Rica in 2010 to that in 2011?
Your answer should be very brief. 1.7. What is the ratio of the Exports(as % of merchandise exports) in Hong Kong in 2010 to that in 2011?
Offer a very short reply. 0.8. What is the ratio of the Exports(as % of merchandise exports) in Iceland in 2010 to that in 2011?
Offer a terse response. 0.53. What is the ratio of the Exports(as % of merchandise exports) of Lower middle income in 2010 to that in 2012?
Offer a terse response. 0.99. What is the ratio of the Exports(as % of merchandise exports) in Costa Rica in 2010 to that in 2012?
Keep it short and to the point. 10.28. What is the ratio of the Exports(as % of merchandise exports) of Hong Kong in 2010 to that in 2012?
Ensure brevity in your answer.  1.03. What is the ratio of the Exports(as % of merchandise exports) of Iceland in 2010 to that in 2012?
Ensure brevity in your answer.  0.51. What is the ratio of the Exports(as % of merchandise exports) of Lower middle income in 2011 to that in 2012?
Offer a terse response. 1.03. What is the ratio of the Exports(as % of merchandise exports) in Costa Rica in 2011 to that in 2012?
Make the answer very short. 6.04. What is the ratio of the Exports(as % of merchandise exports) in Hong Kong in 2011 to that in 2012?
Your answer should be compact. 1.28. What is the ratio of the Exports(as % of merchandise exports) in Iceland in 2011 to that in 2012?
Make the answer very short. 0.96. What is the difference between the highest and the second highest Exports(as % of merchandise exports) in Lower middle income?
Your answer should be very brief. 0.38. What is the difference between the highest and the second highest Exports(as % of merchandise exports) of Costa Rica?
Ensure brevity in your answer.  0.23. What is the difference between the highest and the second highest Exports(as % of merchandise exports) in Hong Kong?
Offer a terse response. 0.32. What is the difference between the highest and the second highest Exports(as % of merchandise exports) of Iceland?
Your answer should be very brief. 0.32. What is the difference between the highest and the lowest Exports(as % of merchandise exports) in Lower middle income?
Your answer should be compact. 2.86. What is the difference between the highest and the lowest Exports(as % of merchandise exports) in Costa Rica?
Your response must be concise. 0.79. What is the difference between the highest and the lowest Exports(as % of merchandise exports) in Hong Kong?
Provide a succinct answer. 2.74. What is the difference between the highest and the lowest Exports(as % of merchandise exports) in Iceland?
Give a very brief answer. 1.34. 